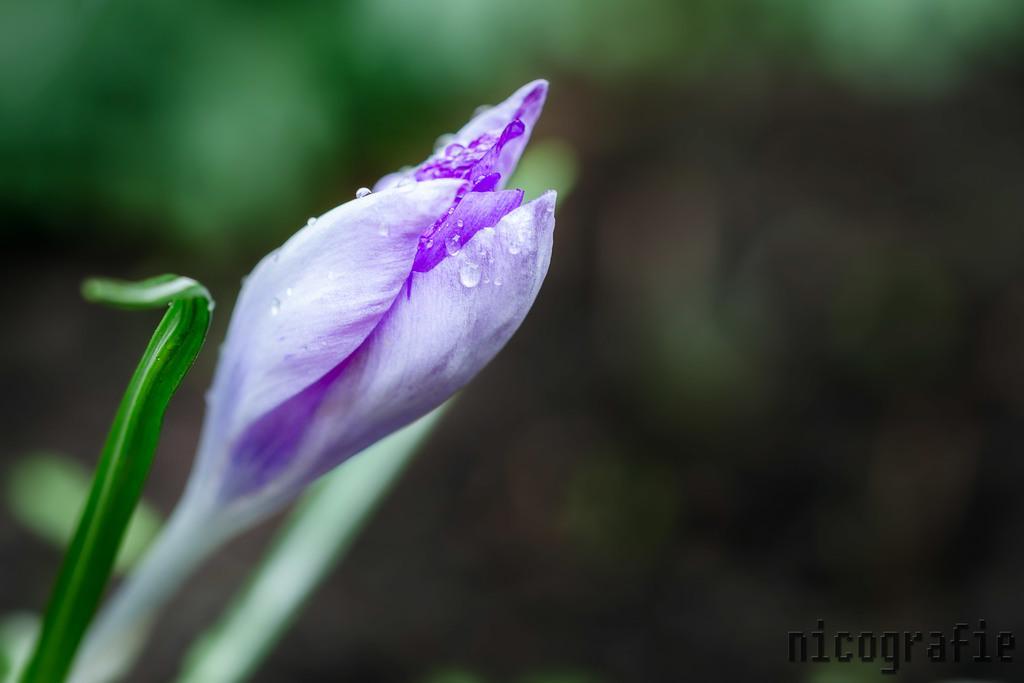Can you describe this image briefly? In this image I can see a flower which is of purple in color and there are few water droplets on it. 